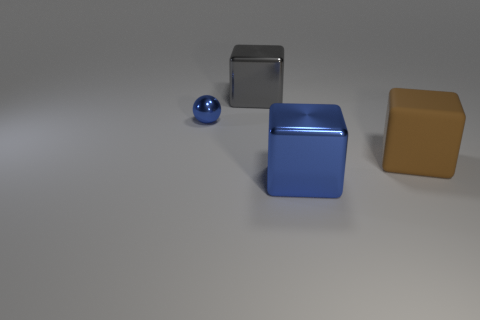Add 4 large blue objects. How many objects exist? 8 Subtract all balls. How many objects are left? 3 Add 3 big objects. How many big objects exist? 6 Subtract 0 gray balls. How many objects are left? 4 Subtract all tiny blue balls. Subtract all blue shiny blocks. How many objects are left? 2 Add 1 shiny blocks. How many shiny blocks are left? 3 